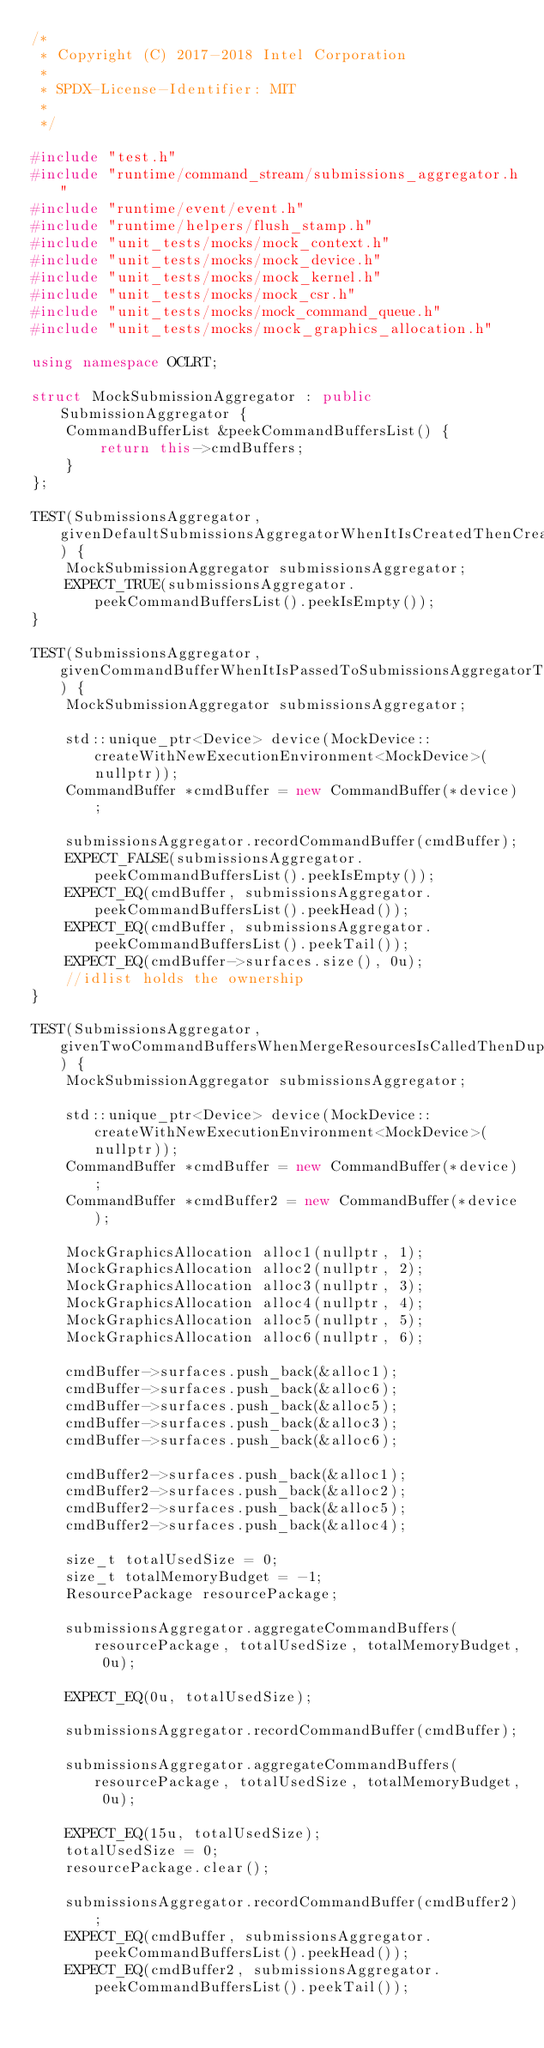<code> <loc_0><loc_0><loc_500><loc_500><_C++_>/*
 * Copyright (C) 2017-2018 Intel Corporation
 *
 * SPDX-License-Identifier: MIT
 *
 */

#include "test.h"
#include "runtime/command_stream/submissions_aggregator.h"
#include "runtime/event/event.h"
#include "runtime/helpers/flush_stamp.h"
#include "unit_tests/mocks/mock_context.h"
#include "unit_tests/mocks/mock_device.h"
#include "unit_tests/mocks/mock_kernel.h"
#include "unit_tests/mocks/mock_csr.h"
#include "unit_tests/mocks/mock_command_queue.h"
#include "unit_tests/mocks/mock_graphics_allocation.h"

using namespace OCLRT;

struct MockSubmissionAggregator : public SubmissionAggregator {
    CommandBufferList &peekCommandBuffersList() {
        return this->cmdBuffers;
    }
};

TEST(SubmissionsAggregator, givenDefaultSubmissionsAggregatorWhenItIsCreatedThenCreationIsSuccesful) {
    MockSubmissionAggregator submissionsAggregator;
    EXPECT_TRUE(submissionsAggregator.peekCommandBuffersList().peekIsEmpty());
}

TEST(SubmissionsAggregator, givenCommandBufferWhenItIsPassedToSubmissionsAggregatorThenItIsRecorded) {
    MockSubmissionAggregator submissionsAggregator;

    std::unique_ptr<Device> device(MockDevice::createWithNewExecutionEnvironment<MockDevice>(nullptr));
    CommandBuffer *cmdBuffer = new CommandBuffer(*device);

    submissionsAggregator.recordCommandBuffer(cmdBuffer);
    EXPECT_FALSE(submissionsAggregator.peekCommandBuffersList().peekIsEmpty());
    EXPECT_EQ(cmdBuffer, submissionsAggregator.peekCommandBuffersList().peekHead());
    EXPECT_EQ(cmdBuffer, submissionsAggregator.peekCommandBuffersList().peekTail());
    EXPECT_EQ(cmdBuffer->surfaces.size(), 0u);
    //idlist holds the ownership
}

TEST(SubmissionsAggregator, givenTwoCommandBuffersWhenMergeResourcesIsCalledThenDuplicatesAreEliminated) {
    MockSubmissionAggregator submissionsAggregator;

    std::unique_ptr<Device> device(MockDevice::createWithNewExecutionEnvironment<MockDevice>(nullptr));
    CommandBuffer *cmdBuffer = new CommandBuffer(*device);
    CommandBuffer *cmdBuffer2 = new CommandBuffer(*device);

    MockGraphicsAllocation alloc1(nullptr, 1);
    MockGraphicsAllocation alloc2(nullptr, 2);
    MockGraphicsAllocation alloc3(nullptr, 3);
    MockGraphicsAllocation alloc4(nullptr, 4);
    MockGraphicsAllocation alloc5(nullptr, 5);
    MockGraphicsAllocation alloc6(nullptr, 6);

    cmdBuffer->surfaces.push_back(&alloc1);
    cmdBuffer->surfaces.push_back(&alloc6);
    cmdBuffer->surfaces.push_back(&alloc5);
    cmdBuffer->surfaces.push_back(&alloc3);
    cmdBuffer->surfaces.push_back(&alloc6);

    cmdBuffer2->surfaces.push_back(&alloc1);
    cmdBuffer2->surfaces.push_back(&alloc2);
    cmdBuffer2->surfaces.push_back(&alloc5);
    cmdBuffer2->surfaces.push_back(&alloc4);

    size_t totalUsedSize = 0;
    size_t totalMemoryBudget = -1;
    ResourcePackage resourcePackage;

    submissionsAggregator.aggregateCommandBuffers(resourcePackage, totalUsedSize, totalMemoryBudget, 0u);

    EXPECT_EQ(0u, totalUsedSize);

    submissionsAggregator.recordCommandBuffer(cmdBuffer);

    submissionsAggregator.aggregateCommandBuffers(resourcePackage, totalUsedSize, totalMemoryBudget, 0u);

    EXPECT_EQ(15u, totalUsedSize);
    totalUsedSize = 0;
    resourcePackage.clear();

    submissionsAggregator.recordCommandBuffer(cmdBuffer2);
    EXPECT_EQ(cmdBuffer, submissionsAggregator.peekCommandBuffersList().peekHead());
    EXPECT_EQ(cmdBuffer2, submissionsAggregator.peekCommandBuffersList().peekTail());</code> 